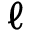<formula> <loc_0><loc_0><loc_500><loc_500>\ell</formula> 